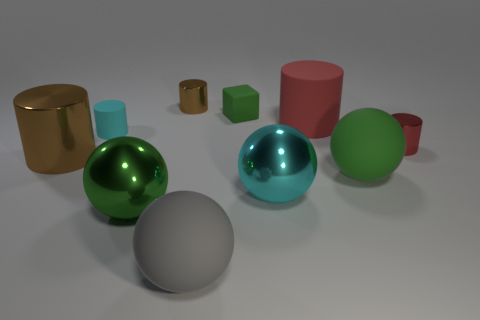Subtract all large green metal spheres. How many spheres are left? 3 Subtract all brown cubes. How many red cylinders are left? 2 Subtract all brown cylinders. How many cylinders are left? 3 Subtract 2 cylinders. How many cylinders are left? 3 Subtract all spheres. How many objects are left? 6 Add 4 brown cylinders. How many brown cylinders are left? 6 Add 4 large gray metallic cylinders. How many large gray metallic cylinders exist? 4 Subtract 1 cyan balls. How many objects are left? 9 Subtract all green cylinders. Subtract all yellow blocks. How many cylinders are left? 5 Subtract all red matte cylinders. Subtract all brown shiny balls. How many objects are left? 9 